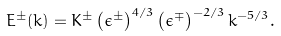Convert formula to latex. <formula><loc_0><loc_0><loc_500><loc_500>E ^ { \pm } ( k ) = K ^ { \pm } \left ( \epsilon ^ { \pm } \right ) ^ { 4 / 3 } \left ( \epsilon ^ { \mp } \right ) ^ { - 2 / 3 } k ^ { - 5 / 3 } .</formula> 